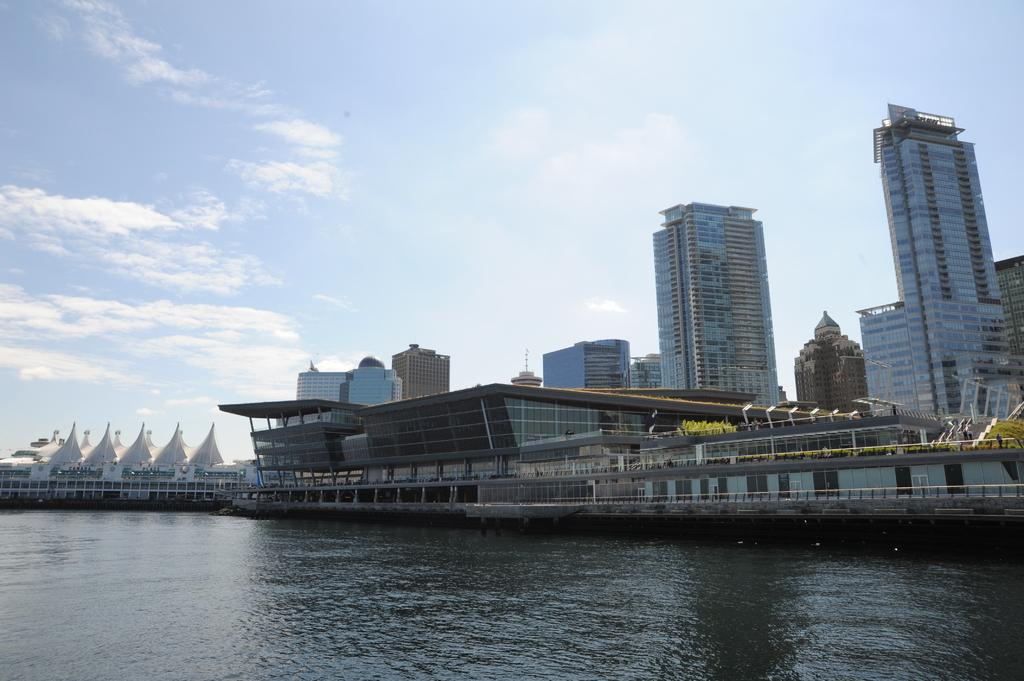What type of structures can be seen in the image? There are buildings in the image. What natural element is visible in the image? There is water visible in the image. What type of vehicles are present in the image? There are boats in the image. What is visible at the top of the image? The sky is visible at the top of the image. Where is the spoon located in the image? There is no spoon present in the image. What type of health services are available in the image? The image does not depict any health services or facilities. 